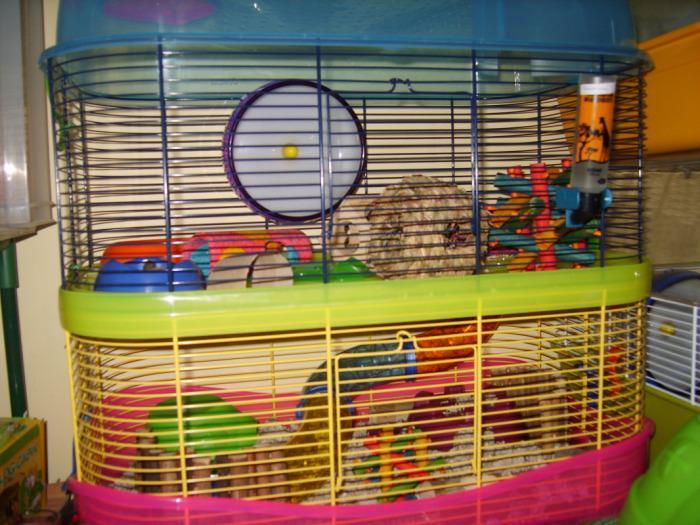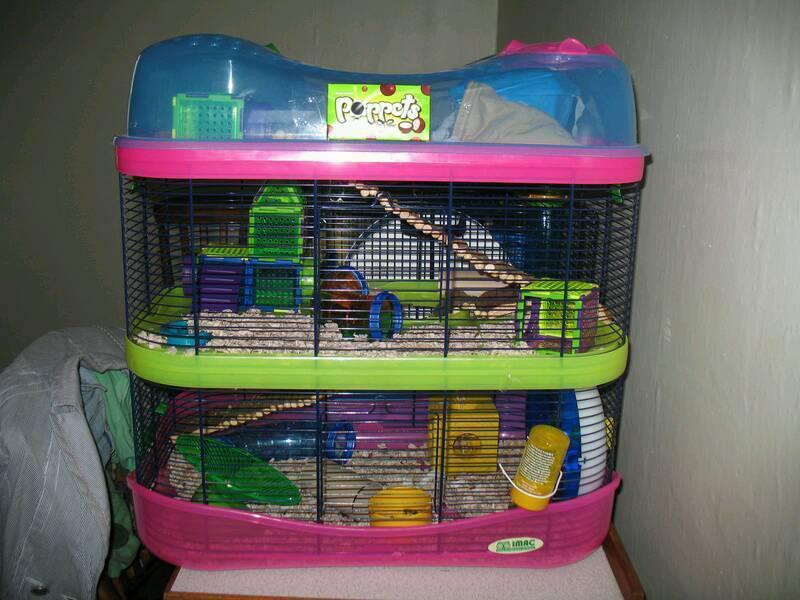The first image is the image on the left, the second image is the image on the right. Evaluate the accuracy of this statement regarding the images: "Both hamster cages have 2 stories.". Is it true? Answer yes or no. Yes. The first image is the image on the left, the second image is the image on the right. Given the left and right images, does the statement "A small pet habitat features a white disk with purple border and yellow dot at the center." hold true? Answer yes or no. Yes. 